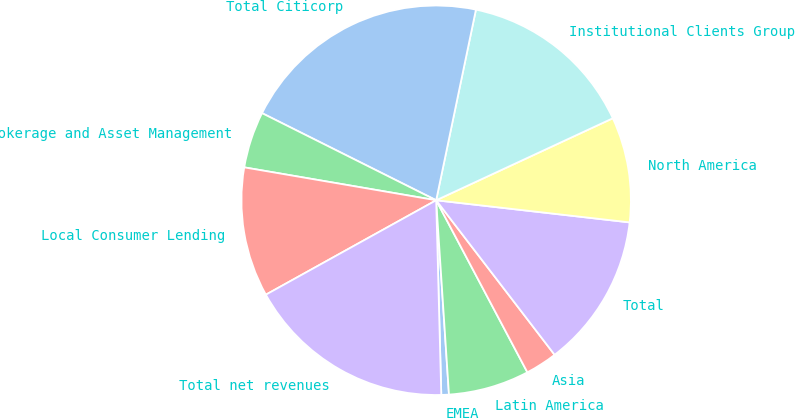Convert chart to OTSL. <chart><loc_0><loc_0><loc_500><loc_500><pie_chart><fcel>EMEA<fcel>Latin America<fcel>Asia<fcel>Total<fcel>North America<fcel>Institutional Clients Group<fcel>Total Citicorp<fcel>Brokerage and Asset Management<fcel>Local Consumer Lending<fcel>Total net revenues<nl><fcel>0.63%<fcel>6.71%<fcel>2.65%<fcel>12.78%<fcel>8.73%<fcel>14.81%<fcel>20.89%<fcel>4.68%<fcel>10.76%<fcel>17.36%<nl></chart> 